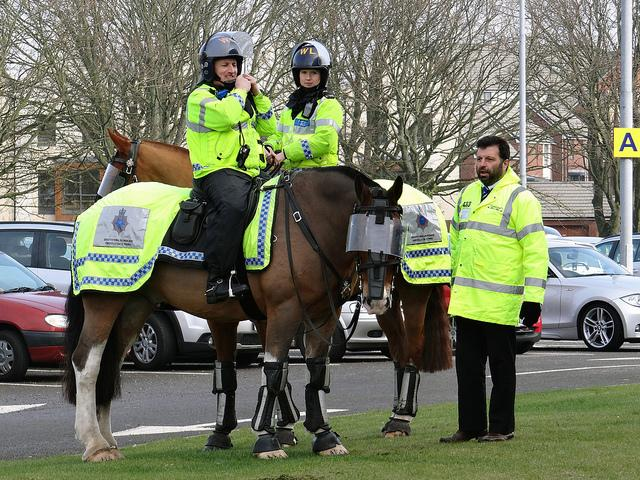What are they preparing for? Please explain your reasoning. riot. These people are preparing for a riot with gear and protection. 